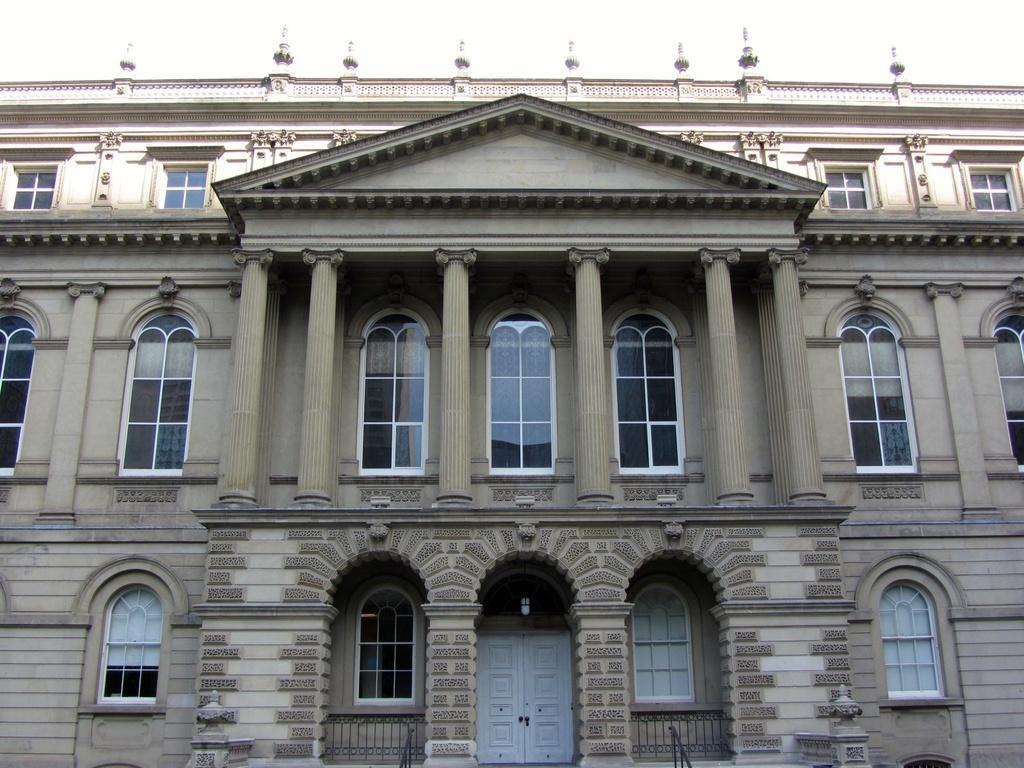Please provide a concise description of this image. In this image we can see the front view of a building and at the top there is sky. 